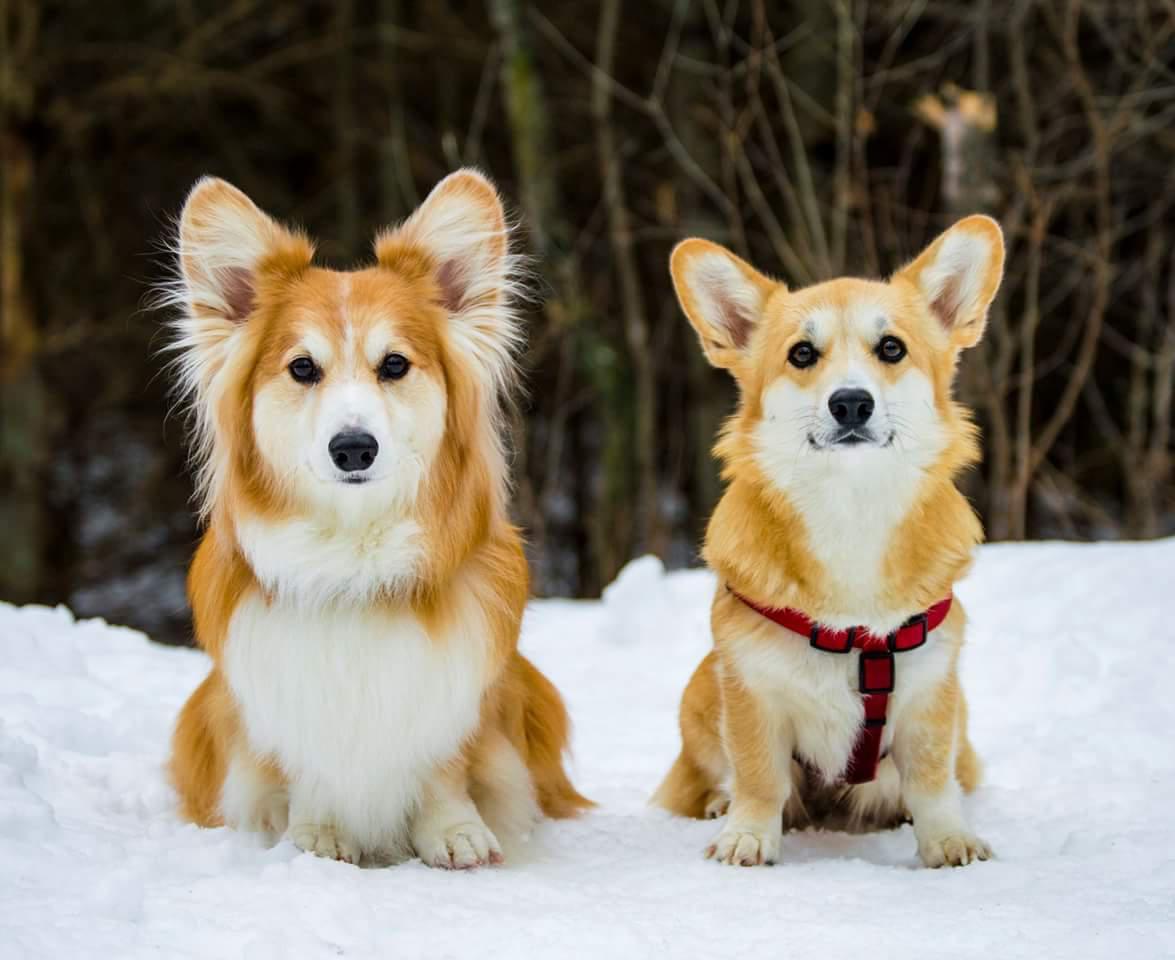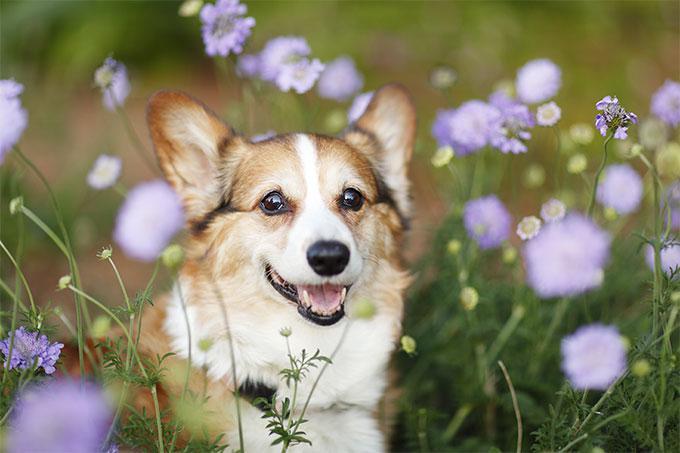The first image is the image on the left, the second image is the image on the right. For the images shown, is this caption "There are only two dogs and neither of them is wearing a hat." true? Answer yes or no. No. The first image is the image on the left, the second image is the image on the right. Given the left and right images, does the statement "At least one dog has it's mouth open." hold true? Answer yes or no. Yes. 